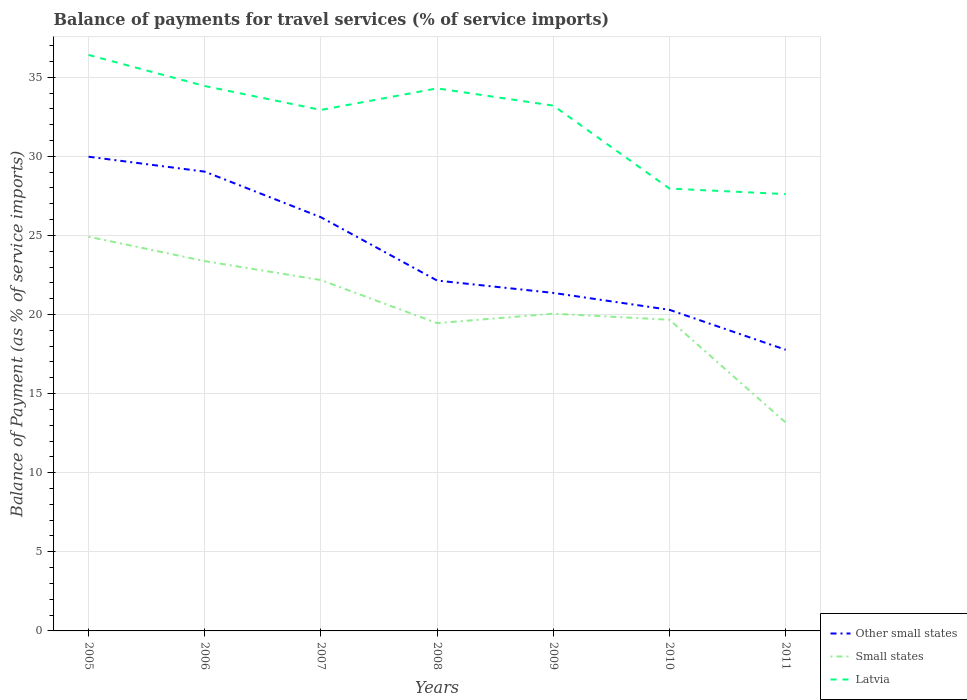How many different coloured lines are there?
Give a very brief answer. 3. Across all years, what is the maximum balance of payments for travel services in Small states?
Your answer should be compact. 13.17. In which year was the balance of payments for travel services in Other small states maximum?
Your response must be concise. 2011. What is the total balance of payments for travel services in Latvia in the graph?
Your response must be concise. 3.47. What is the difference between the highest and the second highest balance of payments for travel services in Latvia?
Ensure brevity in your answer.  8.79. What is the difference between the highest and the lowest balance of payments for travel services in Latvia?
Ensure brevity in your answer.  5. Are the values on the major ticks of Y-axis written in scientific E-notation?
Your response must be concise. No. Does the graph contain grids?
Make the answer very short. Yes. Where does the legend appear in the graph?
Provide a short and direct response. Bottom right. How many legend labels are there?
Make the answer very short. 3. How are the legend labels stacked?
Ensure brevity in your answer.  Vertical. What is the title of the graph?
Make the answer very short. Balance of payments for travel services (% of service imports). What is the label or title of the X-axis?
Make the answer very short. Years. What is the label or title of the Y-axis?
Give a very brief answer. Balance of Payment (as % of service imports). What is the Balance of Payment (as % of service imports) of Other small states in 2005?
Give a very brief answer. 29.97. What is the Balance of Payment (as % of service imports) of Small states in 2005?
Provide a short and direct response. 24.92. What is the Balance of Payment (as % of service imports) in Latvia in 2005?
Offer a very short reply. 36.41. What is the Balance of Payment (as % of service imports) of Other small states in 2006?
Make the answer very short. 29.03. What is the Balance of Payment (as % of service imports) in Small states in 2006?
Provide a short and direct response. 23.38. What is the Balance of Payment (as % of service imports) in Latvia in 2006?
Make the answer very short. 34.44. What is the Balance of Payment (as % of service imports) of Other small states in 2007?
Your answer should be very brief. 26.15. What is the Balance of Payment (as % of service imports) in Small states in 2007?
Make the answer very short. 22.18. What is the Balance of Payment (as % of service imports) in Latvia in 2007?
Your answer should be very brief. 32.93. What is the Balance of Payment (as % of service imports) in Other small states in 2008?
Make the answer very short. 22.15. What is the Balance of Payment (as % of service imports) in Small states in 2008?
Your response must be concise. 19.45. What is the Balance of Payment (as % of service imports) in Latvia in 2008?
Provide a succinct answer. 34.29. What is the Balance of Payment (as % of service imports) of Other small states in 2009?
Your response must be concise. 21.37. What is the Balance of Payment (as % of service imports) in Small states in 2009?
Make the answer very short. 20.05. What is the Balance of Payment (as % of service imports) of Latvia in 2009?
Make the answer very short. 33.2. What is the Balance of Payment (as % of service imports) in Other small states in 2010?
Give a very brief answer. 20.3. What is the Balance of Payment (as % of service imports) of Small states in 2010?
Provide a short and direct response. 19.67. What is the Balance of Payment (as % of service imports) in Latvia in 2010?
Your answer should be compact. 27.96. What is the Balance of Payment (as % of service imports) of Other small states in 2011?
Keep it short and to the point. 17.77. What is the Balance of Payment (as % of service imports) in Small states in 2011?
Your answer should be compact. 13.17. What is the Balance of Payment (as % of service imports) in Latvia in 2011?
Your answer should be compact. 27.61. Across all years, what is the maximum Balance of Payment (as % of service imports) in Other small states?
Your answer should be very brief. 29.97. Across all years, what is the maximum Balance of Payment (as % of service imports) of Small states?
Provide a short and direct response. 24.92. Across all years, what is the maximum Balance of Payment (as % of service imports) in Latvia?
Keep it short and to the point. 36.41. Across all years, what is the minimum Balance of Payment (as % of service imports) in Other small states?
Ensure brevity in your answer.  17.77. Across all years, what is the minimum Balance of Payment (as % of service imports) in Small states?
Offer a very short reply. 13.17. Across all years, what is the minimum Balance of Payment (as % of service imports) in Latvia?
Offer a terse response. 27.61. What is the total Balance of Payment (as % of service imports) of Other small states in the graph?
Your answer should be compact. 166.73. What is the total Balance of Payment (as % of service imports) of Small states in the graph?
Make the answer very short. 142.82. What is the total Balance of Payment (as % of service imports) of Latvia in the graph?
Ensure brevity in your answer.  226.85. What is the difference between the Balance of Payment (as % of service imports) in Other small states in 2005 and that in 2006?
Offer a terse response. 0.94. What is the difference between the Balance of Payment (as % of service imports) of Small states in 2005 and that in 2006?
Make the answer very short. 1.54. What is the difference between the Balance of Payment (as % of service imports) in Latvia in 2005 and that in 2006?
Ensure brevity in your answer.  1.96. What is the difference between the Balance of Payment (as % of service imports) in Other small states in 2005 and that in 2007?
Provide a short and direct response. 3.83. What is the difference between the Balance of Payment (as % of service imports) in Small states in 2005 and that in 2007?
Make the answer very short. 2.74. What is the difference between the Balance of Payment (as % of service imports) of Latvia in 2005 and that in 2007?
Offer a very short reply. 3.47. What is the difference between the Balance of Payment (as % of service imports) in Other small states in 2005 and that in 2008?
Keep it short and to the point. 7.83. What is the difference between the Balance of Payment (as % of service imports) in Small states in 2005 and that in 2008?
Provide a succinct answer. 5.46. What is the difference between the Balance of Payment (as % of service imports) of Latvia in 2005 and that in 2008?
Your response must be concise. 2.11. What is the difference between the Balance of Payment (as % of service imports) of Other small states in 2005 and that in 2009?
Keep it short and to the point. 8.61. What is the difference between the Balance of Payment (as % of service imports) in Small states in 2005 and that in 2009?
Give a very brief answer. 4.87. What is the difference between the Balance of Payment (as % of service imports) in Latvia in 2005 and that in 2009?
Offer a very short reply. 3.2. What is the difference between the Balance of Payment (as % of service imports) of Other small states in 2005 and that in 2010?
Provide a short and direct response. 9.68. What is the difference between the Balance of Payment (as % of service imports) of Small states in 2005 and that in 2010?
Keep it short and to the point. 5.25. What is the difference between the Balance of Payment (as % of service imports) in Latvia in 2005 and that in 2010?
Provide a short and direct response. 8.45. What is the difference between the Balance of Payment (as % of service imports) in Other small states in 2005 and that in 2011?
Provide a short and direct response. 12.2. What is the difference between the Balance of Payment (as % of service imports) of Small states in 2005 and that in 2011?
Ensure brevity in your answer.  11.74. What is the difference between the Balance of Payment (as % of service imports) in Latvia in 2005 and that in 2011?
Provide a succinct answer. 8.79. What is the difference between the Balance of Payment (as % of service imports) in Other small states in 2006 and that in 2007?
Your answer should be compact. 2.88. What is the difference between the Balance of Payment (as % of service imports) in Small states in 2006 and that in 2007?
Your answer should be compact. 1.2. What is the difference between the Balance of Payment (as % of service imports) in Latvia in 2006 and that in 2007?
Ensure brevity in your answer.  1.51. What is the difference between the Balance of Payment (as % of service imports) of Other small states in 2006 and that in 2008?
Make the answer very short. 6.88. What is the difference between the Balance of Payment (as % of service imports) of Small states in 2006 and that in 2008?
Make the answer very short. 3.92. What is the difference between the Balance of Payment (as % of service imports) in Latvia in 2006 and that in 2008?
Give a very brief answer. 0.15. What is the difference between the Balance of Payment (as % of service imports) of Other small states in 2006 and that in 2009?
Offer a terse response. 7.67. What is the difference between the Balance of Payment (as % of service imports) of Small states in 2006 and that in 2009?
Your answer should be compact. 3.32. What is the difference between the Balance of Payment (as % of service imports) in Latvia in 2006 and that in 2009?
Make the answer very short. 1.24. What is the difference between the Balance of Payment (as % of service imports) of Other small states in 2006 and that in 2010?
Offer a terse response. 8.73. What is the difference between the Balance of Payment (as % of service imports) of Small states in 2006 and that in 2010?
Ensure brevity in your answer.  3.71. What is the difference between the Balance of Payment (as % of service imports) in Latvia in 2006 and that in 2010?
Ensure brevity in your answer.  6.48. What is the difference between the Balance of Payment (as % of service imports) of Other small states in 2006 and that in 2011?
Keep it short and to the point. 11.26. What is the difference between the Balance of Payment (as % of service imports) in Small states in 2006 and that in 2011?
Ensure brevity in your answer.  10.2. What is the difference between the Balance of Payment (as % of service imports) in Latvia in 2006 and that in 2011?
Offer a very short reply. 6.83. What is the difference between the Balance of Payment (as % of service imports) of Other small states in 2007 and that in 2008?
Keep it short and to the point. 4. What is the difference between the Balance of Payment (as % of service imports) of Small states in 2007 and that in 2008?
Keep it short and to the point. 2.72. What is the difference between the Balance of Payment (as % of service imports) of Latvia in 2007 and that in 2008?
Offer a very short reply. -1.36. What is the difference between the Balance of Payment (as % of service imports) of Other small states in 2007 and that in 2009?
Give a very brief answer. 4.78. What is the difference between the Balance of Payment (as % of service imports) of Small states in 2007 and that in 2009?
Provide a short and direct response. 2.13. What is the difference between the Balance of Payment (as % of service imports) in Latvia in 2007 and that in 2009?
Keep it short and to the point. -0.27. What is the difference between the Balance of Payment (as % of service imports) in Other small states in 2007 and that in 2010?
Provide a succinct answer. 5.85. What is the difference between the Balance of Payment (as % of service imports) in Small states in 2007 and that in 2010?
Your answer should be very brief. 2.51. What is the difference between the Balance of Payment (as % of service imports) of Latvia in 2007 and that in 2010?
Provide a succinct answer. 4.97. What is the difference between the Balance of Payment (as % of service imports) of Other small states in 2007 and that in 2011?
Offer a very short reply. 8.38. What is the difference between the Balance of Payment (as % of service imports) of Small states in 2007 and that in 2011?
Make the answer very short. 9. What is the difference between the Balance of Payment (as % of service imports) of Latvia in 2007 and that in 2011?
Your response must be concise. 5.32. What is the difference between the Balance of Payment (as % of service imports) in Other small states in 2008 and that in 2009?
Provide a short and direct response. 0.78. What is the difference between the Balance of Payment (as % of service imports) of Small states in 2008 and that in 2009?
Offer a very short reply. -0.6. What is the difference between the Balance of Payment (as % of service imports) of Latvia in 2008 and that in 2009?
Your answer should be compact. 1.09. What is the difference between the Balance of Payment (as % of service imports) in Other small states in 2008 and that in 2010?
Provide a short and direct response. 1.85. What is the difference between the Balance of Payment (as % of service imports) in Small states in 2008 and that in 2010?
Your response must be concise. -0.22. What is the difference between the Balance of Payment (as % of service imports) in Latvia in 2008 and that in 2010?
Provide a succinct answer. 6.33. What is the difference between the Balance of Payment (as % of service imports) in Other small states in 2008 and that in 2011?
Make the answer very short. 4.38. What is the difference between the Balance of Payment (as % of service imports) in Small states in 2008 and that in 2011?
Give a very brief answer. 6.28. What is the difference between the Balance of Payment (as % of service imports) of Latvia in 2008 and that in 2011?
Make the answer very short. 6.68. What is the difference between the Balance of Payment (as % of service imports) in Other small states in 2009 and that in 2010?
Your response must be concise. 1.07. What is the difference between the Balance of Payment (as % of service imports) of Small states in 2009 and that in 2010?
Your response must be concise. 0.38. What is the difference between the Balance of Payment (as % of service imports) of Latvia in 2009 and that in 2010?
Give a very brief answer. 5.24. What is the difference between the Balance of Payment (as % of service imports) in Other small states in 2009 and that in 2011?
Your answer should be very brief. 3.59. What is the difference between the Balance of Payment (as % of service imports) in Small states in 2009 and that in 2011?
Your response must be concise. 6.88. What is the difference between the Balance of Payment (as % of service imports) of Latvia in 2009 and that in 2011?
Offer a terse response. 5.59. What is the difference between the Balance of Payment (as % of service imports) of Other small states in 2010 and that in 2011?
Offer a very short reply. 2.53. What is the difference between the Balance of Payment (as % of service imports) of Small states in 2010 and that in 2011?
Keep it short and to the point. 6.5. What is the difference between the Balance of Payment (as % of service imports) of Latvia in 2010 and that in 2011?
Your answer should be very brief. 0.35. What is the difference between the Balance of Payment (as % of service imports) in Other small states in 2005 and the Balance of Payment (as % of service imports) in Small states in 2006?
Offer a very short reply. 6.6. What is the difference between the Balance of Payment (as % of service imports) of Other small states in 2005 and the Balance of Payment (as % of service imports) of Latvia in 2006?
Offer a very short reply. -4.47. What is the difference between the Balance of Payment (as % of service imports) in Small states in 2005 and the Balance of Payment (as % of service imports) in Latvia in 2006?
Offer a terse response. -9.52. What is the difference between the Balance of Payment (as % of service imports) in Other small states in 2005 and the Balance of Payment (as % of service imports) in Small states in 2007?
Your response must be concise. 7.79. What is the difference between the Balance of Payment (as % of service imports) in Other small states in 2005 and the Balance of Payment (as % of service imports) in Latvia in 2007?
Give a very brief answer. -2.96. What is the difference between the Balance of Payment (as % of service imports) of Small states in 2005 and the Balance of Payment (as % of service imports) of Latvia in 2007?
Provide a short and direct response. -8.01. What is the difference between the Balance of Payment (as % of service imports) in Other small states in 2005 and the Balance of Payment (as % of service imports) in Small states in 2008?
Keep it short and to the point. 10.52. What is the difference between the Balance of Payment (as % of service imports) in Other small states in 2005 and the Balance of Payment (as % of service imports) in Latvia in 2008?
Provide a short and direct response. -4.32. What is the difference between the Balance of Payment (as % of service imports) of Small states in 2005 and the Balance of Payment (as % of service imports) of Latvia in 2008?
Keep it short and to the point. -9.37. What is the difference between the Balance of Payment (as % of service imports) of Other small states in 2005 and the Balance of Payment (as % of service imports) of Small states in 2009?
Offer a terse response. 9.92. What is the difference between the Balance of Payment (as % of service imports) in Other small states in 2005 and the Balance of Payment (as % of service imports) in Latvia in 2009?
Provide a short and direct response. -3.23. What is the difference between the Balance of Payment (as % of service imports) of Small states in 2005 and the Balance of Payment (as % of service imports) of Latvia in 2009?
Give a very brief answer. -8.29. What is the difference between the Balance of Payment (as % of service imports) of Other small states in 2005 and the Balance of Payment (as % of service imports) of Small states in 2010?
Ensure brevity in your answer.  10.3. What is the difference between the Balance of Payment (as % of service imports) in Other small states in 2005 and the Balance of Payment (as % of service imports) in Latvia in 2010?
Your answer should be very brief. 2.01. What is the difference between the Balance of Payment (as % of service imports) in Small states in 2005 and the Balance of Payment (as % of service imports) in Latvia in 2010?
Give a very brief answer. -3.04. What is the difference between the Balance of Payment (as % of service imports) of Other small states in 2005 and the Balance of Payment (as % of service imports) of Small states in 2011?
Ensure brevity in your answer.  16.8. What is the difference between the Balance of Payment (as % of service imports) in Other small states in 2005 and the Balance of Payment (as % of service imports) in Latvia in 2011?
Offer a terse response. 2.36. What is the difference between the Balance of Payment (as % of service imports) in Small states in 2005 and the Balance of Payment (as % of service imports) in Latvia in 2011?
Ensure brevity in your answer.  -2.69. What is the difference between the Balance of Payment (as % of service imports) of Other small states in 2006 and the Balance of Payment (as % of service imports) of Small states in 2007?
Your answer should be very brief. 6.85. What is the difference between the Balance of Payment (as % of service imports) in Other small states in 2006 and the Balance of Payment (as % of service imports) in Latvia in 2007?
Give a very brief answer. -3.9. What is the difference between the Balance of Payment (as % of service imports) of Small states in 2006 and the Balance of Payment (as % of service imports) of Latvia in 2007?
Offer a terse response. -9.56. What is the difference between the Balance of Payment (as % of service imports) in Other small states in 2006 and the Balance of Payment (as % of service imports) in Small states in 2008?
Your answer should be compact. 9.58. What is the difference between the Balance of Payment (as % of service imports) in Other small states in 2006 and the Balance of Payment (as % of service imports) in Latvia in 2008?
Give a very brief answer. -5.26. What is the difference between the Balance of Payment (as % of service imports) of Small states in 2006 and the Balance of Payment (as % of service imports) of Latvia in 2008?
Offer a terse response. -10.92. What is the difference between the Balance of Payment (as % of service imports) in Other small states in 2006 and the Balance of Payment (as % of service imports) in Small states in 2009?
Your answer should be compact. 8.98. What is the difference between the Balance of Payment (as % of service imports) of Other small states in 2006 and the Balance of Payment (as % of service imports) of Latvia in 2009?
Offer a very short reply. -4.17. What is the difference between the Balance of Payment (as % of service imports) of Small states in 2006 and the Balance of Payment (as % of service imports) of Latvia in 2009?
Give a very brief answer. -9.83. What is the difference between the Balance of Payment (as % of service imports) in Other small states in 2006 and the Balance of Payment (as % of service imports) in Small states in 2010?
Offer a very short reply. 9.36. What is the difference between the Balance of Payment (as % of service imports) in Other small states in 2006 and the Balance of Payment (as % of service imports) in Latvia in 2010?
Your answer should be very brief. 1.07. What is the difference between the Balance of Payment (as % of service imports) in Small states in 2006 and the Balance of Payment (as % of service imports) in Latvia in 2010?
Provide a short and direct response. -4.58. What is the difference between the Balance of Payment (as % of service imports) in Other small states in 2006 and the Balance of Payment (as % of service imports) in Small states in 2011?
Your answer should be compact. 15.86. What is the difference between the Balance of Payment (as % of service imports) in Other small states in 2006 and the Balance of Payment (as % of service imports) in Latvia in 2011?
Keep it short and to the point. 1.42. What is the difference between the Balance of Payment (as % of service imports) of Small states in 2006 and the Balance of Payment (as % of service imports) of Latvia in 2011?
Your answer should be very brief. -4.24. What is the difference between the Balance of Payment (as % of service imports) in Other small states in 2007 and the Balance of Payment (as % of service imports) in Small states in 2008?
Ensure brevity in your answer.  6.69. What is the difference between the Balance of Payment (as % of service imports) of Other small states in 2007 and the Balance of Payment (as % of service imports) of Latvia in 2008?
Provide a succinct answer. -8.14. What is the difference between the Balance of Payment (as % of service imports) in Small states in 2007 and the Balance of Payment (as % of service imports) in Latvia in 2008?
Give a very brief answer. -12.11. What is the difference between the Balance of Payment (as % of service imports) in Other small states in 2007 and the Balance of Payment (as % of service imports) in Small states in 2009?
Keep it short and to the point. 6.1. What is the difference between the Balance of Payment (as % of service imports) of Other small states in 2007 and the Balance of Payment (as % of service imports) of Latvia in 2009?
Provide a short and direct response. -7.06. What is the difference between the Balance of Payment (as % of service imports) of Small states in 2007 and the Balance of Payment (as % of service imports) of Latvia in 2009?
Ensure brevity in your answer.  -11.02. What is the difference between the Balance of Payment (as % of service imports) in Other small states in 2007 and the Balance of Payment (as % of service imports) in Small states in 2010?
Keep it short and to the point. 6.48. What is the difference between the Balance of Payment (as % of service imports) in Other small states in 2007 and the Balance of Payment (as % of service imports) in Latvia in 2010?
Make the answer very short. -1.81. What is the difference between the Balance of Payment (as % of service imports) in Small states in 2007 and the Balance of Payment (as % of service imports) in Latvia in 2010?
Keep it short and to the point. -5.78. What is the difference between the Balance of Payment (as % of service imports) in Other small states in 2007 and the Balance of Payment (as % of service imports) in Small states in 2011?
Provide a succinct answer. 12.97. What is the difference between the Balance of Payment (as % of service imports) of Other small states in 2007 and the Balance of Payment (as % of service imports) of Latvia in 2011?
Your response must be concise. -1.46. What is the difference between the Balance of Payment (as % of service imports) in Small states in 2007 and the Balance of Payment (as % of service imports) in Latvia in 2011?
Your answer should be compact. -5.43. What is the difference between the Balance of Payment (as % of service imports) in Other small states in 2008 and the Balance of Payment (as % of service imports) in Small states in 2009?
Offer a very short reply. 2.09. What is the difference between the Balance of Payment (as % of service imports) in Other small states in 2008 and the Balance of Payment (as % of service imports) in Latvia in 2009?
Provide a succinct answer. -11.06. What is the difference between the Balance of Payment (as % of service imports) of Small states in 2008 and the Balance of Payment (as % of service imports) of Latvia in 2009?
Your response must be concise. -13.75. What is the difference between the Balance of Payment (as % of service imports) of Other small states in 2008 and the Balance of Payment (as % of service imports) of Small states in 2010?
Provide a succinct answer. 2.48. What is the difference between the Balance of Payment (as % of service imports) of Other small states in 2008 and the Balance of Payment (as % of service imports) of Latvia in 2010?
Your response must be concise. -5.81. What is the difference between the Balance of Payment (as % of service imports) in Small states in 2008 and the Balance of Payment (as % of service imports) in Latvia in 2010?
Offer a terse response. -8.51. What is the difference between the Balance of Payment (as % of service imports) of Other small states in 2008 and the Balance of Payment (as % of service imports) of Small states in 2011?
Your answer should be compact. 8.97. What is the difference between the Balance of Payment (as % of service imports) of Other small states in 2008 and the Balance of Payment (as % of service imports) of Latvia in 2011?
Offer a very short reply. -5.46. What is the difference between the Balance of Payment (as % of service imports) in Small states in 2008 and the Balance of Payment (as % of service imports) in Latvia in 2011?
Your answer should be very brief. -8.16. What is the difference between the Balance of Payment (as % of service imports) of Other small states in 2009 and the Balance of Payment (as % of service imports) of Small states in 2010?
Your answer should be compact. 1.7. What is the difference between the Balance of Payment (as % of service imports) of Other small states in 2009 and the Balance of Payment (as % of service imports) of Latvia in 2010?
Ensure brevity in your answer.  -6.59. What is the difference between the Balance of Payment (as % of service imports) of Small states in 2009 and the Balance of Payment (as % of service imports) of Latvia in 2010?
Ensure brevity in your answer.  -7.91. What is the difference between the Balance of Payment (as % of service imports) of Other small states in 2009 and the Balance of Payment (as % of service imports) of Small states in 2011?
Provide a short and direct response. 8.19. What is the difference between the Balance of Payment (as % of service imports) in Other small states in 2009 and the Balance of Payment (as % of service imports) in Latvia in 2011?
Keep it short and to the point. -6.25. What is the difference between the Balance of Payment (as % of service imports) in Small states in 2009 and the Balance of Payment (as % of service imports) in Latvia in 2011?
Keep it short and to the point. -7.56. What is the difference between the Balance of Payment (as % of service imports) of Other small states in 2010 and the Balance of Payment (as % of service imports) of Small states in 2011?
Ensure brevity in your answer.  7.12. What is the difference between the Balance of Payment (as % of service imports) in Other small states in 2010 and the Balance of Payment (as % of service imports) in Latvia in 2011?
Give a very brief answer. -7.31. What is the difference between the Balance of Payment (as % of service imports) of Small states in 2010 and the Balance of Payment (as % of service imports) of Latvia in 2011?
Provide a succinct answer. -7.94. What is the average Balance of Payment (as % of service imports) of Other small states per year?
Offer a very short reply. 23.82. What is the average Balance of Payment (as % of service imports) in Small states per year?
Offer a terse response. 20.4. What is the average Balance of Payment (as % of service imports) in Latvia per year?
Your answer should be compact. 32.41. In the year 2005, what is the difference between the Balance of Payment (as % of service imports) of Other small states and Balance of Payment (as % of service imports) of Small states?
Your answer should be very brief. 5.06. In the year 2005, what is the difference between the Balance of Payment (as % of service imports) in Other small states and Balance of Payment (as % of service imports) in Latvia?
Provide a short and direct response. -6.43. In the year 2005, what is the difference between the Balance of Payment (as % of service imports) of Small states and Balance of Payment (as % of service imports) of Latvia?
Offer a terse response. -11.49. In the year 2006, what is the difference between the Balance of Payment (as % of service imports) of Other small states and Balance of Payment (as % of service imports) of Small states?
Provide a short and direct response. 5.66. In the year 2006, what is the difference between the Balance of Payment (as % of service imports) of Other small states and Balance of Payment (as % of service imports) of Latvia?
Your response must be concise. -5.41. In the year 2006, what is the difference between the Balance of Payment (as % of service imports) in Small states and Balance of Payment (as % of service imports) in Latvia?
Offer a terse response. -11.07. In the year 2007, what is the difference between the Balance of Payment (as % of service imports) of Other small states and Balance of Payment (as % of service imports) of Small states?
Keep it short and to the point. 3.97. In the year 2007, what is the difference between the Balance of Payment (as % of service imports) of Other small states and Balance of Payment (as % of service imports) of Latvia?
Make the answer very short. -6.78. In the year 2007, what is the difference between the Balance of Payment (as % of service imports) in Small states and Balance of Payment (as % of service imports) in Latvia?
Ensure brevity in your answer.  -10.75. In the year 2008, what is the difference between the Balance of Payment (as % of service imports) in Other small states and Balance of Payment (as % of service imports) in Small states?
Give a very brief answer. 2.69. In the year 2008, what is the difference between the Balance of Payment (as % of service imports) in Other small states and Balance of Payment (as % of service imports) in Latvia?
Offer a very short reply. -12.15. In the year 2008, what is the difference between the Balance of Payment (as % of service imports) in Small states and Balance of Payment (as % of service imports) in Latvia?
Offer a very short reply. -14.84. In the year 2009, what is the difference between the Balance of Payment (as % of service imports) of Other small states and Balance of Payment (as % of service imports) of Small states?
Provide a short and direct response. 1.31. In the year 2009, what is the difference between the Balance of Payment (as % of service imports) in Other small states and Balance of Payment (as % of service imports) in Latvia?
Make the answer very short. -11.84. In the year 2009, what is the difference between the Balance of Payment (as % of service imports) in Small states and Balance of Payment (as % of service imports) in Latvia?
Provide a succinct answer. -13.15. In the year 2010, what is the difference between the Balance of Payment (as % of service imports) in Other small states and Balance of Payment (as % of service imports) in Small states?
Your response must be concise. 0.63. In the year 2010, what is the difference between the Balance of Payment (as % of service imports) of Other small states and Balance of Payment (as % of service imports) of Latvia?
Your answer should be very brief. -7.66. In the year 2010, what is the difference between the Balance of Payment (as % of service imports) of Small states and Balance of Payment (as % of service imports) of Latvia?
Make the answer very short. -8.29. In the year 2011, what is the difference between the Balance of Payment (as % of service imports) of Other small states and Balance of Payment (as % of service imports) of Small states?
Offer a very short reply. 4.6. In the year 2011, what is the difference between the Balance of Payment (as % of service imports) of Other small states and Balance of Payment (as % of service imports) of Latvia?
Provide a short and direct response. -9.84. In the year 2011, what is the difference between the Balance of Payment (as % of service imports) of Small states and Balance of Payment (as % of service imports) of Latvia?
Make the answer very short. -14.44. What is the ratio of the Balance of Payment (as % of service imports) in Other small states in 2005 to that in 2006?
Your response must be concise. 1.03. What is the ratio of the Balance of Payment (as % of service imports) of Small states in 2005 to that in 2006?
Your answer should be very brief. 1.07. What is the ratio of the Balance of Payment (as % of service imports) in Latvia in 2005 to that in 2006?
Offer a terse response. 1.06. What is the ratio of the Balance of Payment (as % of service imports) in Other small states in 2005 to that in 2007?
Offer a terse response. 1.15. What is the ratio of the Balance of Payment (as % of service imports) in Small states in 2005 to that in 2007?
Provide a short and direct response. 1.12. What is the ratio of the Balance of Payment (as % of service imports) in Latvia in 2005 to that in 2007?
Make the answer very short. 1.11. What is the ratio of the Balance of Payment (as % of service imports) in Other small states in 2005 to that in 2008?
Keep it short and to the point. 1.35. What is the ratio of the Balance of Payment (as % of service imports) in Small states in 2005 to that in 2008?
Provide a succinct answer. 1.28. What is the ratio of the Balance of Payment (as % of service imports) of Latvia in 2005 to that in 2008?
Your answer should be very brief. 1.06. What is the ratio of the Balance of Payment (as % of service imports) of Other small states in 2005 to that in 2009?
Provide a short and direct response. 1.4. What is the ratio of the Balance of Payment (as % of service imports) of Small states in 2005 to that in 2009?
Offer a very short reply. 1.24. What is the ratio of the Balance of Payment (as % of service imports) in Latvia in 2005 to that in 2009?
Ensure brevity in your answer.  1.1. What is the ratio of the Balance of Payment (as % of service imports) of Other small states in 2005 to that in 2010?
Offer a very short reply. 1.48. What is the ratio of the Balance of Payment (as % of service imports) in Small states in 2005 to that in 2010?
Give a very brief answer. 1.27. What is the ratio of the Balance of Payment (as % of service imports) in Latvia in 2005 to that in 2010?
Make the answer very short. 1.3. What is the ratio of the Balance of Payment (as % of service imports) in Other small states in 2005 to that in 2011?
Your answer should be compact. 1.69. What is the ratio of the Balance of Payment (as % of service imports) of Small states in 2005 to that in 2011?
Offer a terse response. 1.89. What is the ratio of the Balance of Payment (as % of service imports) of Latvia in 2005 to that in 2011?
Your answer should be very brief. 1.32. What is the ratio of the Balance of Payment (as % of service imports) of Other small states in 2006 to that in 2007?
Keep it short and to the point. 1.11. What is the ratio of the Balance of Payment (as % of service imports) in Small states in 2006 to that in 2007?
Your answer should be compact. 1.05. What is the ratio of the Balance of Payment (as % of service imports) in Latvia in 2006 to that in 2007?
Provide a short and direct response. 1.05. What is the ratio of the Balance of Payment (as % of service imports) of Other small states in 2006 to that in 2008?
Provide a succinct answer. 1.31. What is the ratio of the Balance of Payment (as % of service imports) in Small states in 2006 to that in 2008?
Keep it short and to the point. 1.2. What is the ratio of the Balance of Payment (as % of service imports) of Latvia in 2006 to that in 2008?
Provide a short and direct response. 1. What is the ratio of the Balance of Payment (as % of service imports) of Other small states in 2006 to that in 2009?
Provide a short and direct response. 1.36. What is the ratio of the Balance of Payment (as % of service imports) of Small states in 2006 to that in 2009?
Provide a succinct answer. 1.17. What is the ratio of the Balance of Payment (as % of service imports) in Latvia in 2006 to that in 2009?
Provide a short and direct response. 1.04. What is the ratio of the Balance of Payment (as % of service imports) of Other small states in 2006 to that in 2010?
Offer a terse response. 1.43. What is the ratio of the Balance of Payment (as % of service imports) in Small states in 2006 to that in 2010?
Provide a short and direct response. 1.19. What is the ratio of the Balance of Payment (as % of service imports) of Latvia in 2006 to that in 2010?
Your answer should be compact. 1.23. What is the ratio of the Balance of Payment (as % of service imports) of Other small states in 2006 to that in 2011?
Your answer should be very brief. 1.63. What is the ratio of the Balance of Payment (as % of service imports) in Small states in 2006 to that in 2011?
Give a very brief answer. 1.77. What is the ratio of the Balance of Payment (as % of service imports) of Latvia in 2006 to that in 2011?
Provide a short and direct response. 1.25. What is the ratio of the Balance of Payment (as % of service imports) of Other small states in 2007 to that in 2008?
Give a very brief answer. 1.18. What is the ratio of the Balance of Payment (as % of service imports) in Small states in 2007 to that in 2008?
Provide a short and direct response. 1.14. What is the ratio of the Balance of Payment (as % of service imports) in Latvia in 2007 to that in 2008?
Ensure brevity in your answer.  0.96. What is the ratio of the Balance of Payment (as % of service imports) of Other small states in 2007 to that in 2009?
Offer a terse response. 1.22. What is the ratio of the Balance of Payment (as % of service imports) in Small states in 2007 to that in 2009?
Your answer should be very brief. 1.11. What is the ratio of the Balance of Payment (as % of service imports) of Other small states in 2007 to that in 2010?
Provide a short and direct response. 1.29. What is the ratio of the Balance of Payment (as % of service imports) of Small states in 2007 to that in 2010?
Ensure brevity in your answer.  1.13. What is the ratio of the Balance of Payment (as % of service imports) of Latvia in 2007 to that in 2010?
Offer a very short reply. 1.18. What is the ratio of the Balance of Payment (as % of service imports) in Other small states in 2007 to that in 2011?
Offer a terse response. 1.47. What is the ratio of the Balance of Payment (as % of service imports) of Small states in 2007 to that in 2011?
Your answer should be very brief. 1.68. What is the ratio of the Balance of Payment (as % of service imports) of Latvia in 2007 to that in 2011?
Offer a terse response. 1.19. What is the ratio of the Balance of Payment (as % of service imports) in Other small states in 2008 to that in 2009?
Your response must be concise. 1.04. What is the ratio of the Balance of Payment (as % of service imports) in Small states in 2008 to that in 2009?
Offer a very short reply. 0.97. What is the ratio of the Balance of Payment (as % of service imports) of Latvia in 2008 to that in 2009?
Make the answer very short. 1.03. What is the ratio of the Balance of Payment (as % of service imports) in Other small states in 2008 to that in 2010?
Provide a succinct answer. 1.09. What is the ratio of the Balance of Payment (as % of service imports) of Latvia in 2008 to that in 2010?
Provide a short and direct response. 1.23. What is the ratio of the Balance of Payment (as % of service imports) in Other small states in 2008 to that in 2011?
Offer a terse response. 1.25. What is the ratio of the Balance of Payment (as % of service imports) of Small states in 2008 to that in 2011?
Keep it short and to the point. 1.48. What is the ratio of the Balance of Payment (as % of service imports) in Latvia in 2008 to that in 2011?
Give a very brief answer. 1.24. What is the ratio of the Balance of Payment (as % of service imports) in Other small states in 2009 to that in 2010?
Provide a succinct answer. 1.05. What is the ratio of the Balance of Payment (as % of service imports) in Small states in 2009 to that in 2010?
Give a very brief answer. 1.02. What is the ratio of the Balance of Payment (as % of service imports) in Latvia in 2009 to that in 2010?
Give a very brief answer. 1.19. What is the ratio of the Balance of Payment (as % of service imports) in Other small states in 2009 to that in 2011?
Your response must be concise. 1.2. What is the ratio of the Balance of Payment (as % of service imports) of Small states in 2009 to that in 2011?
Your answer should be very brief. 1.52. What is the ratio of the Balance of Payment (as % of service imports) of Latvia in 2009 to that in 2011?
Your response must be concise. 1.2. What is the ratio of the Balance of Payment (as % of service imports) of Other small states in 2010 to that in 2011?
Give a very brief answer. 1.14. What is the ratio of the Balance of Payment (as % of service imports) of Small states in 2010 to that in 2011?
Ensure brevity in your answer.  1.49. What is the ratio of the Balance of Payment (as % of service imports) in Latvia in 2010 to that in 2011?
Provide a short and direct response. 1.01. What is the difference between the highest and the second highest Balance of Payment (as % of service imports) of Other small states?
Ensure brevity in your answer.  0.94. What is the difference between the highest and the second highest Balance of Payment (as % of service imports) of Small states?
Make the answer very short. 1.54. What is the difference between the highest and the second highest Balance of Payment (as % of service imports) of Latvia?
Keep it short and to the point. 1.96. What is the difference between the highest and the lowest Balance of Payment (as % of service imports) of Other small states?
Ensure brevity in your answer.  12.2. What is the difference between the highest and the lowest Balance of Payment (as % of service imports) of Small states?
Your answer should be very brief. 11.74. What is the difference between the highest and the lowest Balance of Payment (as % of service imports) of Latvia?
Keep it short and to the point. 8.79. 